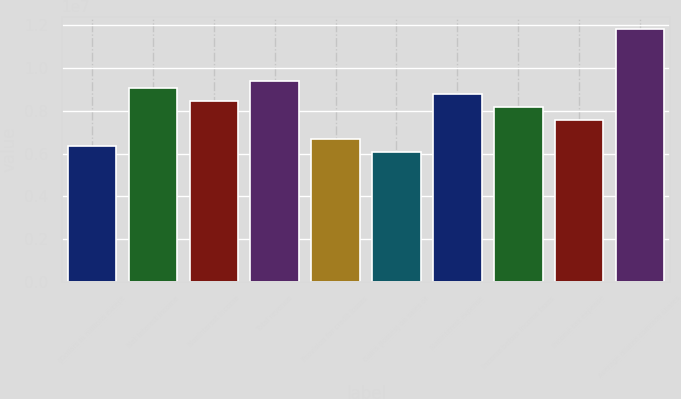Convert chart to OTSL. <chart><loc_0><loc_0><loc_500><loc_500><bar_chart><fcel>(Dollars in millions except<fcel>Net interest income<fcel>Noninterest income<fcel>Total revenue<fcel>Provision for credit losses<fcel>Gains (losses) on sales of<fcel>Noninterest expense<fcel>Income before income taxes<fcel>Income tax expense<fcel>Average diluted common shares<nl><fcel>6.36375e+06<fcel>9.09107e+06<fcel>8.485e+06<fcel>9.3941e+06<fcel>6.66678e+06<fcel>6.06071e+06<fcel>8.78803e+06<fcel>8.18196e+06<fcel>7.57589e+06<fcel>1.18184e+07<nl></chart> 